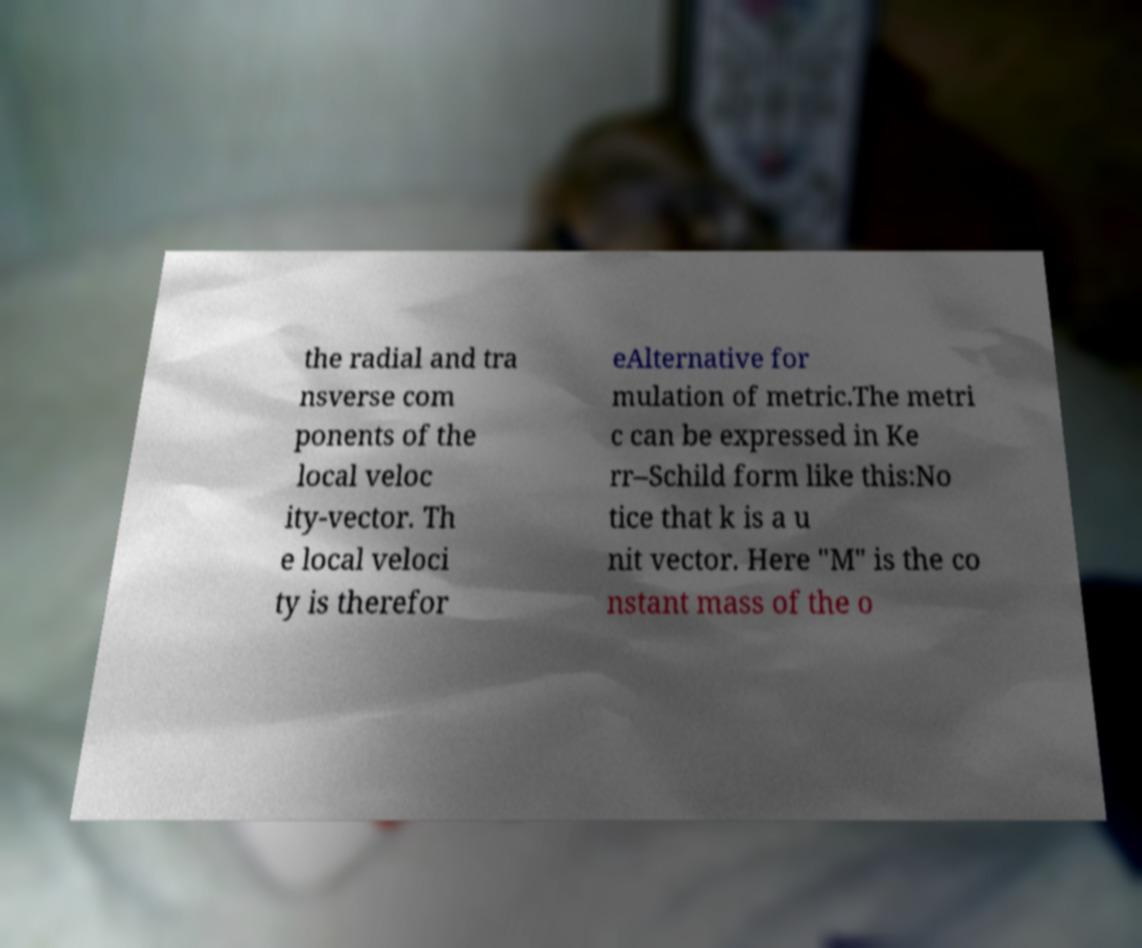For documentation purposes, I need the text within this image transcribed. Could you provide that? the radial and tra nsverse com ponents of the local veloc ity-vector. Th e local veloci ty is therefor eAlternative for mulation of metric.The metri c can be expressed in Ke rr–Schild form like this:No tice that k is a u nit vector. Here "M" is the co nstant mass of the o 